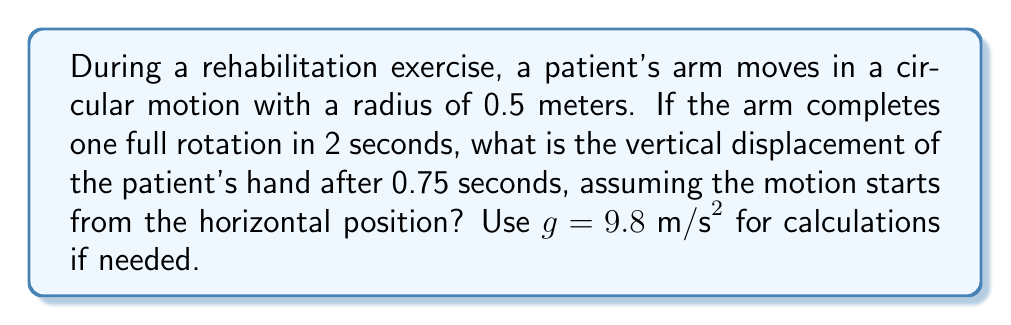Can you answer this question? Let's approach this step-by-step:

1) First, we need to determine the angular velocity $\omega$:
   $$\omega = \frac{2\pi}{T} = \frac{2\pi}{2 \text{ s}} = \pi \text{ rad/s}$$

2) The motion starts from the horizontal position, so we can use a cosine function to describe the vertical position $y$ at time $t$:
   $$y(t) = r \cos(\omega t + \frac{\pi}{2})$$
   
   Where $r$ is the radius, and we add $\frac{\pi}{2}$ to start from the horizontal position.

3) Given values:
   $r = 0.5 \text{ m}$
   $t = 0.75 \text{ s}$
   $\omega = \pi \text{ rad/s}$

4) Substituting these into our equation:
   $$y(0.75) = 0.5 \cos(\pi \cdot 0.75 + \frac{\pi}{2})$$

5) Simplify inside the parentheses:
   $$y(0.75) = 0.5 \cos(\frac{3\pi}{4} + \frac{\pi}{2}) = 0.5 \cos(\frac{5\pi}{4})$$

6) Calculate:
   $$y(0.75) = 0.5 \cdot (-\frac{\sqrt{2}}{2}) = -0.5 \cdot \frac{\sqrt{2}}{2} \text{ m}$$

7) Simplify:
   $$y(0.75) = -\frac{\sqrt{2}}{4} \text{ m} \approx -0.3536 \text{ m}$$

The negative sign indicates that the hand is below the horizontal position.
Answer: $-\frac{\sqrt{2}}{4} \text{ m}$ or approximately $-0.3536 \text{ m}$ 